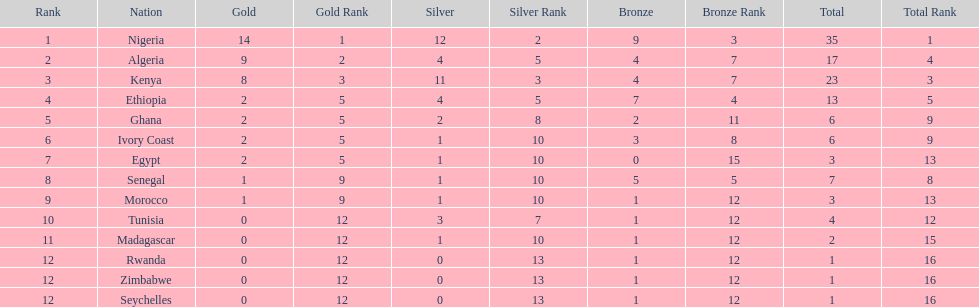The team before algeria Nigeria. 